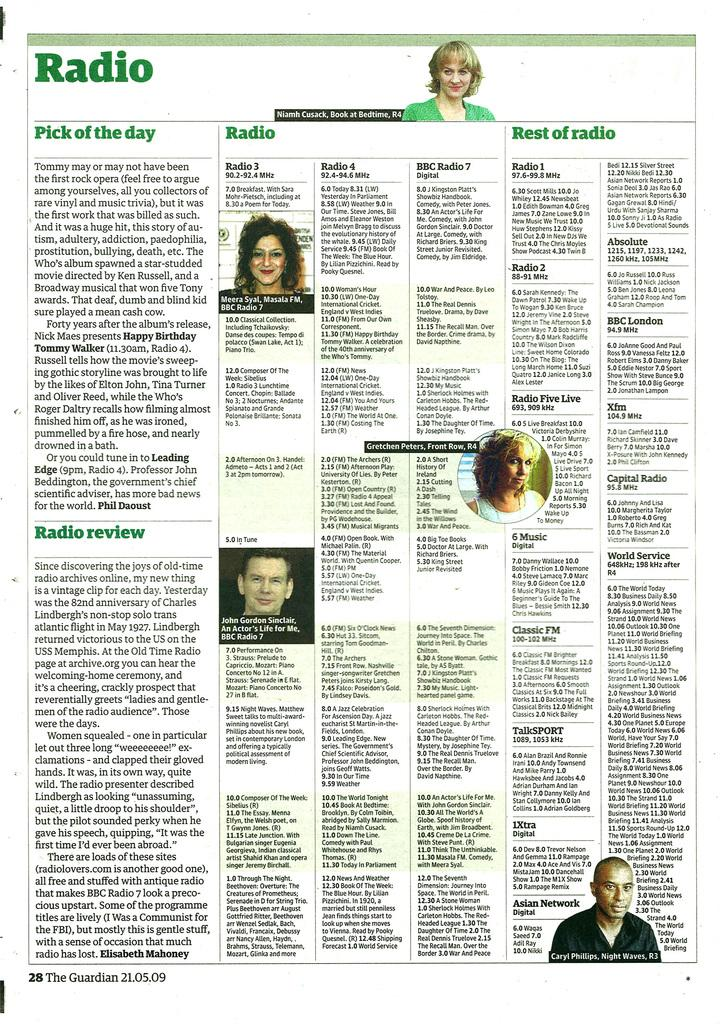What is the main object in the image? There is a newspaper in the image. What can be found on the newspaper? The newspaper has text and pictures printed on it. What type of bee can be seen playing chess on the newspaper in the image? There is no bee or chess game present in the image; it only mentions a newspaper with text and pictures. 